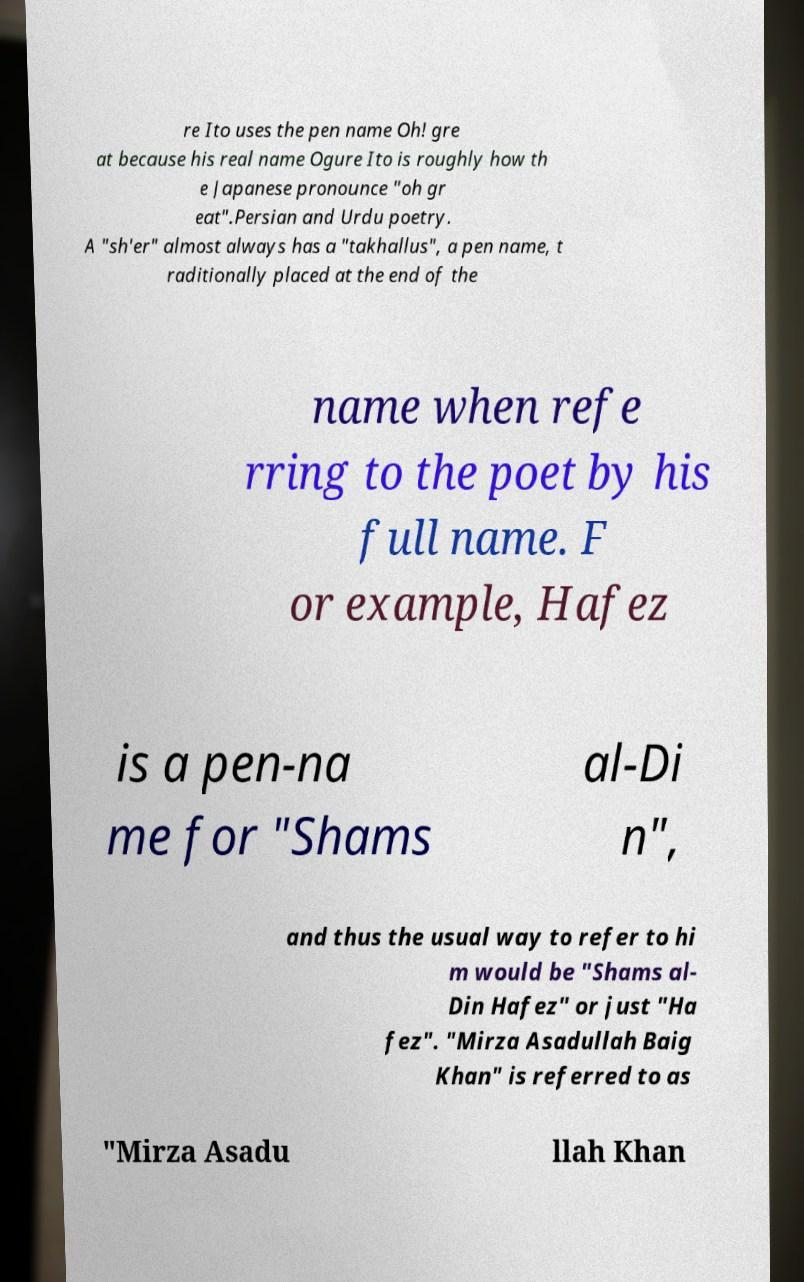Can you read and provide the text displayed in the image?This photo seems to have some interesting text. Can you extract and type it out for me? re Ito uses the pen name Oh! gre at because his real name Ogure Ito is roughly how th e Japanese pronounce "oh gr eat".Persian and Urdu poetry. A "sh'er" almost always has a "takhallus", a pen name, t raditionally placed at the end of the name when refe rring to the poet by his full name. F or example, Hafez is a pen-na me for "Shams al-Di n", and thus the usual way to refer to hi m would be "Shams al- Din Hafez" or just "Ha fez". "Mirza Asadullah Baig Khan" is referred to as "Mirza Asadu llah Khan 